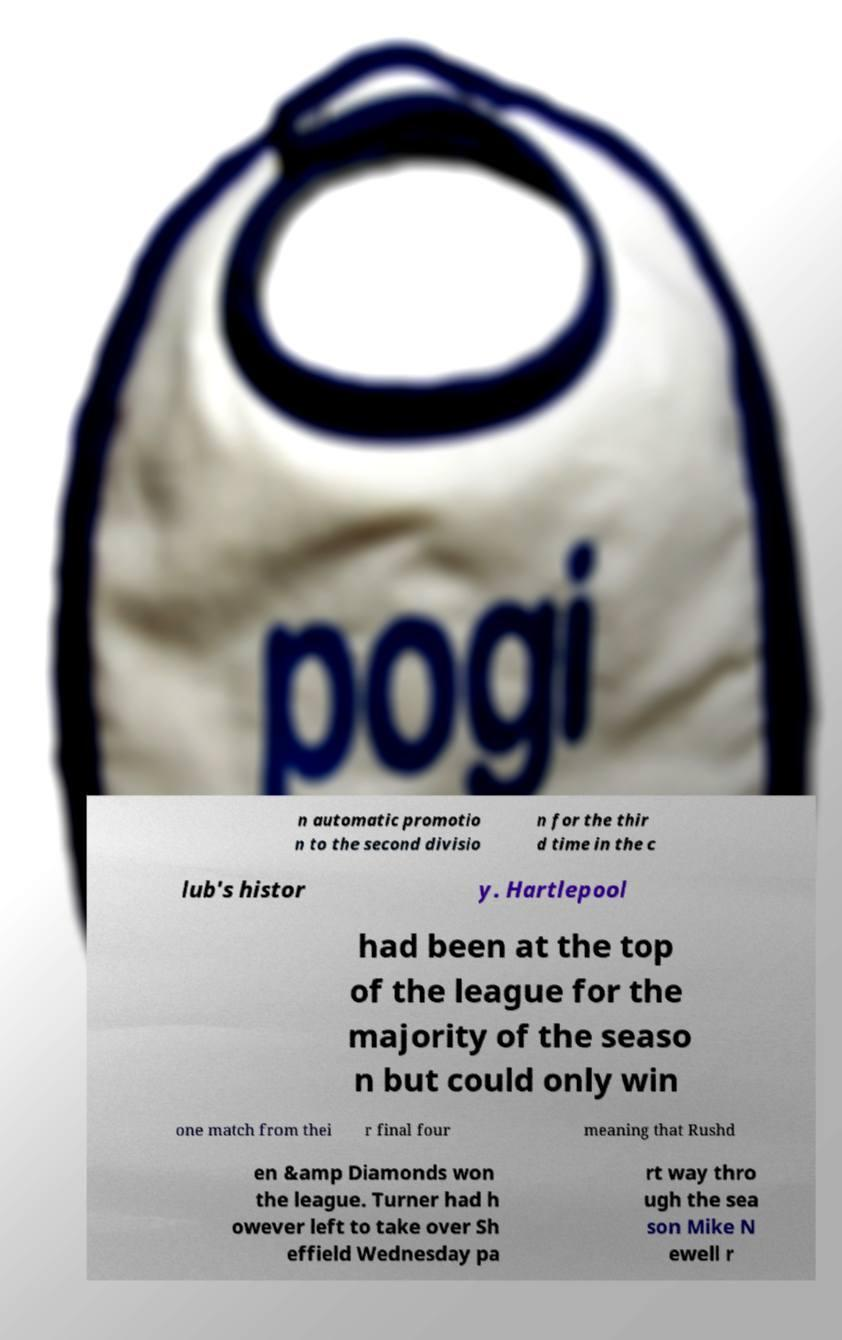Can you accurately transcribe the text from the provided image for me? n automatic promotio n to the second divisio n for the thir d time in the c lub's histor y. Hartlepool had been at the top of the league for the majority of the seaso n but could only win one match from thei r final four meaning that Rushd en &amp Diamonds won the league. Turner had h owever left to take over Sh effield Wednesday pa rt way thro ugh the sea son Mike N ewell r 